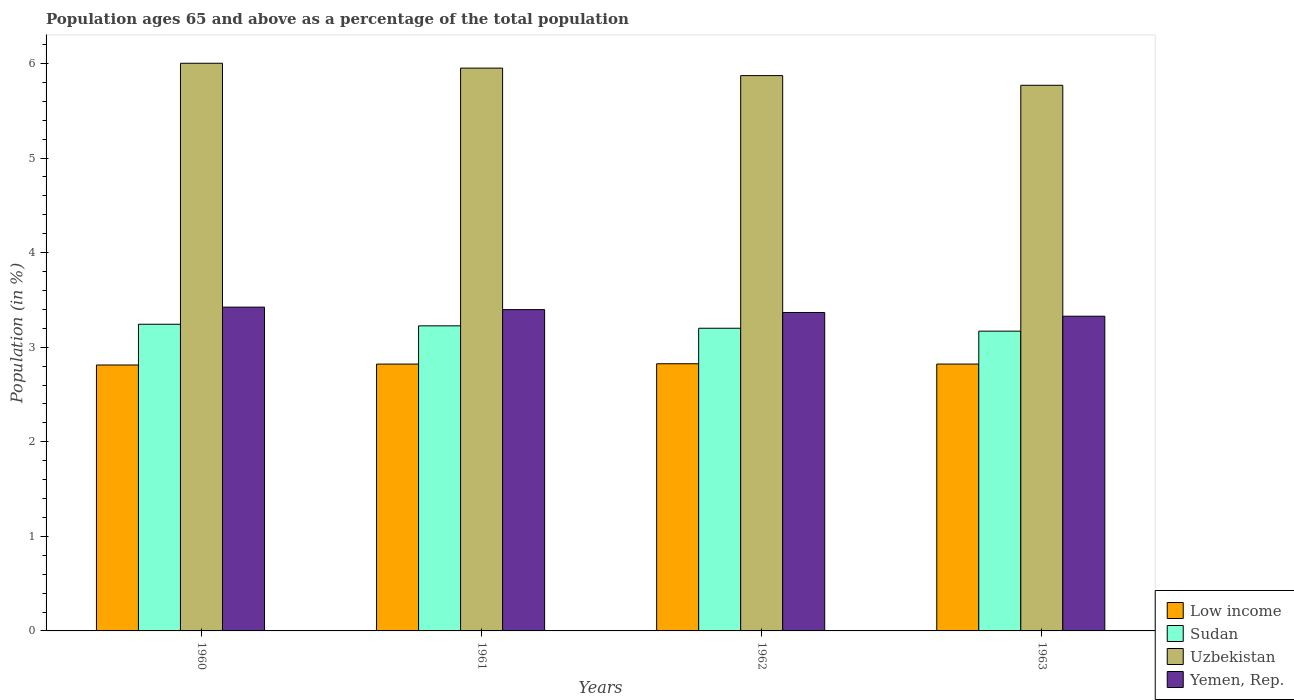How many different coloured bars are there?
Give a very brief answer. 4. How many groups of bars are there?
Ensure brevity in your answer.  4. Are the number of bars on each tick of the X-axis equal?
Ensure brevity in your answer.  Yes. How many bars are there on the 2nd tick from the left?
Your answer should be very brief. 4. What is the label of the 1st group of bars from the left?
Provide a short and direct response. 1960. What is the percentage of the population ages 65 and above in Uzbekistan in 1963?
Ensure brevity in your answer.  5.77. Across all years, what is the maximum percentage of the population ages 65 and above in Yemen, Rep.?
Your response must be concise. 3.42. Across all years, what is the minimum percentage of the population ages 65 and above in Sudan?
Make the answer very short. 3.17. In which year was the percentage of the population ages 65 and above in Sudan maximum?
Offer a very short reply. 1960. In which year was the percentage of the population ages 65 and above in Sudan minimum?
Offer a terse response. 1963. What is the total percentage of the population ages 65 and above in Low income in the graph?
Your response must be concise. 11.28. What is the difference between the percentage of the population ages 65 and above in Uzbekistan in 1960 and that in 1963?
Ensure brevity in your answer.  0.23. What is the difference between the percentage of the population ages 65 and above in Sudan in 1961 and the percentage of the population ages 65 and above in Uzbekistan in 1960?
Make the answer very short. -2.78. What is the average percentage of the population ages 65 and above in Yemen, Rep. per year?
Ensure brevity in your answer.  3.38. In the year 1963, what is the difference between the percentage of the population ages 65 and above in Yemen, Rep. and percentage of the population ages 65 and above in Uzbekistan?
Ensure brevity in your answer.  -2.44. In how many years, is the percentage of the population ages 65 and above in Low income greater than 4.8?
Offer a terse response. 0. What is the ratio of the percentage of the population ages 65 and above in Sudan in 1960 to that in 1963?
Keep it short and to the point. 1.02. What is the difference between the highest and the second highest percentage of the population ages 65 and above in Low income?
Make the answer very short. 0. What is the difference between the highest and the lowest percentage of the population ages 65 and above in Low income?
Your answer should be very brief. 0.01. Is the sum of the percentage of the population ages 65 and above in Low income in 1960 and 1961 greater than the maximum percentage of the population ages 65 and above in Yemen, Rep. across all years?
Provide a short and direct response. Yes. What does the 3rd bar from the left in 1960 represents?
Ensure brevity in your answer.  Uzbekistan. What does the 2nd bar from the right in 1962 represents?
Provide a succinct answer. Uzbekistan. Does the graph contain any zero values?
Your response must be concise. No. Does the graph contain grids?
Make the answer very short. No. Where does the legend appear in the graph?
Your answer should be very brief. Bottom right. How many legend labels are there?
Ensure brevity in your answer.  4. How are the legend labels stacked?
Your answer should be very brief. Vertical. What is the title of the graph?
Your response must be concise. Population ages 65 and above as a percentage of the total population. Does "Venezuela" appear as one of the legend labels in the graph?
Ensure brevity in your answer.  No. What is the label or title of the X-axis?
Give a very brief answer. Years. What is the label or title of the Y-axis?
Your answer should be compact. Population (in %). What is the Population (in %) in Low income in 1960?
Offer a terse response. 2.81. What is the Population (in %) of Sudan in 1960?
Make the answer very short. 3.24. What is the Population (in %) in Uzbekistan in 1960?
Your answer should be very brief. 6. What is the Population (in %) in Yemen, Rep. in 1960?
Your response must be concise. 3.42. What is the Population (in %) of Low income in 1961?
Give a very brief answer. 2.82. What is the Population (in %) in Sudan in 1961?
Keep it short and to the point. 3.23. What is the Population (in %) of Uzbekistan in 1961?
Make the answer very short. 5.95. What is the Population (in %) of Yemen, Rep. in 1961?
Give a very brief answer. 3.4. What is the Population (in %) of Low income in 1962?
Keep it short and to the point. 2.82. What is the Population (in %) in Sudan in 1962?
Offer a very short reply. 3.2. What is the Population (in %) in Uzbekistan in 1962?
Your answer should be very brief. 5.87. What is the Population (in %) in Yemen, Rep. in 1962?
Ensure brevity in your answer.  3.37. What is the Population (in %) in Low income in 1963?
Give a very brief answer. 2.82. What is the Population (in %) in Sudan in 1963?
Provide a short and direct response. 3.17. What is the Population (in %) of Uzbekistan in 1963?
Keep it short and to the point. 5.77. What is the Population (in %) in Yemen, Rep. in 1963?
Provide a succinct answer. 3.33. Across all years, what is the maximum Population (in %) of Low income?
Offer a terse response. 2.82. Across all years, what is the maximum Population (in %) in Sudan?
Your answer should be compact. 3.24. Across all years, what is the maximum Population (in %) of Uzbekistan?
Give a very brief answer. 6. Across all years, what is the maximum Population (in %) in Yemen, Rep.?
Your answer should be compact. 3.42. Across all years, what is the minimum Population (in %) in Low income?
Make the answer very short. 2.81. Across all years, what is the minimum Population (in %) of Sudan?
Your answer should be compact. 3.17. Across all years, what is the minimum Population (in %) in Uzbekistan?
Offer a very short reply. 5.77. Across all years, what is the minimum Population (in %) of Yemen, Rep.?
Your answer should be very brief. 3.33. What is the total Population (in %) in Low income in the graph?
Provide a succinct answer. 11.28. What is the total Population (in %) in Sudan in the graph?
Provide a succinct answer. 12.84. What is the total Population (in %) of Uzbekistan in the graph?
Keep it short and to the point. 23.59. What is the total Population (in %) of Yemen, Rep. in the graph?
Offer a very short reply. 13.51. What is the difference between the Population (in %) of Low income in 1960 and that in 1961?
Your answer should be compact. -0.01. What is the difference between the Population (in %) in Sudan in 1960 and that in 1961?
Provide a succinct answer. 0.02. What is the difference between the Population (in %) of Uzbekistan in 1960 and that in 1961?
Your response must be concise. 0.05. What is the difference between the Population (in %) of Yemen, Rep. in 1960 and that in 1961?
Make the answer very short. 0.03. What is the difference between the Population (in %) of Low income in 1960 and that in 1962?
Offer a terse response. -0.01. What is the difference between the Population (in %) of Sudan in 1960 and that in 1962?
Your answer should be very brief. 0.04. What is the difference between the Population (in %) of Uzbekistan in 1960 and that in 1962?
Offer a terse response. 0.13. What is the difference between the Population (in %) in Yemen, Rep. in 1960 and that in 1962?
Ensure brevity in your answer.  0.06. What is the difference between the Population (in %) of Low income in 1960 and that in 1963?
Provide a succinct answer. -0.01. What is the difference between the Population (in %) of Sudan in 1960 and that in 1963?
Give a very brief answer. 0.07. What is the difference between the Population (in %) of Uzbekistan in 1960 and that in 1963?
Your answer should be compact. 0.23. What is the difference between the Population (in %) in Yemen, Rep. in 1960 and that in 1963?
Your response must be concise. 0.1. What is the difference between the Population (in %) in Low income in 1961 and that in 1962?
Give a very brief answer. -0. What is the difference between the Population (in %) of Sudan in 1961 and that in 1962?
Ensure brevity in your answer.  0.03. What is the difference between the Population (in %) in Uzbekistan in 1961 and that in 1962?
Make the answer very short. 0.08. What is the difference between the Population (in %) of Yemen, Rep. in 1961 and that in 1962?
Keep it short and to the point. 0.03. What is the difference between the Population (in %) of Low income in 1961 and that in 1963?
Your answer should be compact. -0. What is the difference between the Population (in %) in Sudan in 1961 and that in 1963?
Offer a very short reply. 0.06. What is the difference between the Population (in %) in Uzbekistan in 1961 and that in 1963?
Give a very brief answer. 0.18. What is the difference between the Population (in %) of Yemen, Rep. in 1961 and that in 1963?
Your answer should be compact. 0.07. What is the difference between the Population (in %) of Low income in 1962 and that in 1963?
Ensure brevity in your answer.  0. What is the difference between the Population (in %) of Sudan in 1962 and that in 1963?
Provide a succinct answer. 0.03. What is the difference between the Population (in %) of Uzbekistan in 1962 and that in 1963?
Offer a terse response. 0.1. What is the difference between the Population (in %) of Yemen, Rep. in 1962 and that in 1963?
Provide a succinct answer. 0.04. What is the difference between the Population (in %) in Low income in 1960 and the Population (in %) in Sudan in 1961?
Keep it short and to the point. -0.41. What is the difference between the Population (in %) in Low income in 1960 and the Population (in %) in Uzbekistan in 1961?
Your response must be concise. -3.14. What is the difference between the Population (in %) in Low income in 1960 and the Population (in %) in Yemen, Rep. in 1961?
Give a very brief answer. -0.59. What is the difference between the Population (in %) of Sudan in 1960 and the Population (in %) of Uzbekistan in 1961?
Your answer should be compact. -2.71. What is the difference between the Population (in %) of Sudan in 1960 and the Population (in %) of Yemen, Rep. in 1961?
Your response must be concise. -0.15. What is the difference between the Population (in %) in Uzbekistan in 1960 and the Population (in %) in Yemen, Rep. in 1961?
Your response must be concise. 2.6. What is the difference between the Population (in %) of Low income in 1960 and the Population (in %) of Sudan in 1962?
Provide a short and direct response. -0.39. What is the difference between the Population (in %) in Low income in 1960 and the Population (in %) in Uzbekistan in 1962?
Keep it short and to the point. -3.06. What is the difference between the Population (in %) of Low income in 1960 and the Population (in %) of Yemen, Rep. in 1962?
Give a very brief answer. -0.55. What is the difference between the Population (in %) in Sudan in 1960 and the Population (in %) in Uzbekistan in 1962?
Your response must be concise. -2.63. What is the difference between the Population (in %) of Sudan in 1960 and the Population (in %) of Yemen, Rep. in 1962?
Your answer should be very brief. -0.12. What is the difference between the Population (in %) in Uzbekistan in 1960 and the Population (in %) in Yemen, Rep. in 1962?
Your answer should be very brief. 2.64. What is the difference between the Population (in %) of Low income in 1960 and the Population (in %) of Sudan in 1963?
Offer a very short reply. -0.36. What is the difference between the Population (in %) of Low income in 1960 and the Population (in %) of Uzbekistan in 1963?
Ensure brevity in your answer.  -2.96. What is the difference between the Population (in %) of Low income in 1960 and the Population (in %) of Yemen, Rep. in 1963?
Provide a succinct answer. -0.52. What is the difference between the Population (in %) of Sudan in 1960 and the Population (in %) of Uzbekistan in 1963?
Make the answer very short. -2.53. What is the difference between the Population (in %) in Sudan in 1960 and the Population (in %) in Yemen, Rep. in 1963?
Offer a terse response. -0.09. What is the difference between the Population (in %) in Uzbekistan in 1960 and the Population (in %) in Yemen, Rep. in 1963?
Keep it short and to the point. 2.67. What is the difference between the Population (in %) of Low income in 1961 and the Population (in %) of Sudan in 1962?
Your answer should be compact. -0.38. What is the difference between the Population (in %) of Low income in 1961 and the Population (in %) of Uzbekistan in 1962?
Ensure brevity in your answer.  -3.05. What is the difference between the Population (in %) of Low income in 1961 and the Population (in %) of Yemen, Rep. in 1962?
Offer a terse response. -0.55. What is the difference between the Population (in %) in Sudan in 1961 and the Population (in %) in Uzbekistan in 1962?
Offer a terse response. -2.65. What is the difference between the Population (in %) in Sudan in 1961 and the Population (in %) in Yemen, Rep. in 1962?
Your response must be concise. -0.14. What is the difference between the Population (in %) in Uzbekistan in 1961 and the Population (in %) in Yemen, Rep. in 1962?
Give a very brief answer. 2.58. What is the difference between the Population (in %) in Low income in 1961 and the Population (in %) in Sudan in 1963?
Your answer should be very brief. -0.35. What is the difference between the Population (in %) in Low income in 1961 and the Population (in %) in Uzbekistan in 1963?
Ensure brevity in your answer.  -2.95. What is the difference between the Population (in %) in Low income in 1961 and the Population (in %) in Yemen, Rep. in 1963?
Offer a very short reply. -0.51. What is the difference between the Population (in %) in Sudan in 1961 and the Population (in %) in Uzbekistan in 1963?
Offer a very short reply. -2.54. What is the difference between the Population (in %) of Sudan in 1961 and the Population (in %) of Yemen, Rep. in 1963?
Provide a short and direct response. -0.1. What is the difference between the Population (in %) of Uzbekistan in 1961 and the Population (in %) of Yemen, Rep. in 1963?
Give a very brief answer. 2.62. What is the difference between the Population (in %) in Low income in 1962 and the Population (in %) in Sudan in 1963?
Your response must be concise. -0.34. What is the difference between the Population (in %) in Low income in 1962 and the Population (in %) in Uzbekistan in 1963?
Provide a succinct answer. -2.94. What is the difference between the Population (in %) in Low income in 1962 and the Population (in %) in Yemen, Rep. in 1963?
Offer a terse response. -0.5. What is the difference between the Population (in %) of Sudan in 1962 and the Population (in %) of Uzbekistan in 1963?
Your answer should be very brief. -2.57. What is the difference between the Population (in %) of Sudan in 1962 and the Population (in %) of Yemen, Rep. in 1963?
Offer a terse response. -0.13. What is the difference between the Population (in %) in Uzbekistan in 1962 and the Population (in %) in Yemen, Rep. in 1963?
Ensure brevity in your answer.  2.54. What is the average Population (in %) of Low income per year?
Your answer should be very brief. 2.82. What is the average Population (in %) in Sudan per year?
Your answer should be very brief. 3.21. What is the average Population (in %) of Uzbekistan per year?
Your answer should be compact. 5.9. What is the average Population (in %) of Yemen, Rep. per year?
Give a very brief answer. 3.38. In the year 1960, what is the difference between the Population (in %) in Low income and Population (in %) in Sudan?
Your answer should be very brief. -0.43. In the year 1960, what is the difference between the Population (in %) of Low income and Population (in %) of Uzbekistan?
Your response must be concise. -3.19. In the year 1960, what is the difference between the Population (in %) of Low income and Population (in %) of Yemen, Rep.?
Keep it short and to the point. -0.61. In the year 1960, what is the difference between the Population (in %) in Sudan and Population (in %) in Uzbekistan?
Offer a very short reply. -2.76. In the year 1960, what is the difference between the Population (in %) of Sudan and Population (in %) of Yemen, Rep.?
Your answer should be very brief. -0.18. In the year 1960, what is the difference between the Population (in %) of Uzbekistan and Population (in %) of Yemen, Rep.?
Provide a succinct answer. 2.58. In the year 1961, what is the difference between the Population (in %) in Low income and Population (in %) in Sudan?
Your answer should be compact. -0.4. In the year 1961, what is the difference between the Population (in %) of Low income and Population (in %) of Uzbekistan?
Provide a short and direct response. -3.13. In the year 1961, what is the difference between the Population (in %) of Low income and Population (in %) of Yemen, Rep.?
Provide a succinct answer. -0.58. In the year 1961, what is the difference between the Population (in %) of Sudan and Population (in %) of Uzbekistan?
Give a very brief answer. -2.72. In the year 1961, what is the difference between the Population (in %) in Sudan and Population (in %) in Yemen, Rep.?
Give a very brief answer. -0.17. In the year 1961, what is the difference between the Population (in %) in Uzbekistan and Population (in %) in Yemen, Rep.?
Offer a very short reply. 2.55. In the year 1962, what is the difference between the Population (in %) of Low income and Population (in %) of Sudan?
Offer a very short reply. -0.38. In the year 1962, what is the difference between the Population (in %) of Low income and Population (in %) of Uzbekistan?
Your response must be concise. -3.05. In the year 1962, what is the difference between the Population (in %) of Low income and Population (in %) of Yemen, Rep.?
Make the answer very short. -0.54. In the year 1962, what is the difference between the Population (in %) of Sudan and Population (in %) of Uzbekistan?
Keep it short and to the point. -2.67. In the year 1962, what is the difference between the Population (in %) of Sudan and Population (in %) of Yemen, Rep.?
Your answer should be very brief. -0.17. In the year 1962, what is the difference between the Population (in %) in Uzbekistan and Population (in %) in Yemen, Rep.?
Offer a terse response. 2.5. In the year 1963, what is the difference between the Population (in %) in Low income and Population (in %) in Sudan?
Your answer should be compact. -0.35. In the year 1963, what is the difference between the Population (in %) of Low income and Population (in %) of Uzbekistan?
Offer a very short reply. -2.95. In the year 1963, what is the difference between the Population (in %) of Low income and Population (in %) of Yemen, Rep.?
Keep it short and to the point. -0.51. In the year 1963, what is the difference between the Population (in %) in Sudan and Population (in %) in Uzbekistan?
Provide a succinct answer. -2.6. In the year 1963, what is the difference between the Population (in %) in Sudan and Population (in %) in Yemen, Rep.?
Ensure brevity in your answer.  -0.16. In the year 1963, what is the difference between the Population (in %) of Uzbekistan and Population (in %) of Yemen, Rep.?
Your response must be concise. 2.44. What is the ratio of the Population (in %) of Uzbekistan in 1960 to that in 1961?
Ensure brevity in your answer.  1.01. What is the ratio of the Population (in %) of Yemen, Rep. in 1960 to that in 1961?
Offer a terse response. 1.01. What is the ratio of the Population (in %) of Sudan in 1960 to that in 1962?
Make the answer very short. 1.01. What is the ratio of the Population (in %) of Uzbekistan in 1960 to that in 1962?
Give a very brief answer. 1.02. What is the ratio of the Population (in %) in Yemen, Rep. in 1960 to that in 1962?
Keep it short and to the point. 1.02. What is the ratio of the Population (in %) of Uzbekistan in 1960 to that in 1963?
Keep it short and to the point. 1.04. What is the ratio of the Population (in %) of Yemen, Rep. in 1960 to that in 1963?
Provide a short and direct response. 1.03. What is the ratio of the Population (in %) of Sudan in 1961 to that in 1962?
Give a very brief answer. 1.01. What is the ratio of the Population (in %) in Uzbekistan in 1961 to that in 1962?
Your answer should be very brief. 1.01. What is the ratio of the Population (in %) of Yemen, Rep. in 1961 to that in 1962?
Provide a succinct answer. 1.01. What is the ratio of the Population (in %) of Low income in 1961 to that in 1963?
Offer a very short reply. 1. What is the ratio of the Population (in %) of Sudan in 1961 to that in 1963?
Offer a very short reply. 1.02. What is the ratio of the Population (in %) in Uzbekistan in 1961 to that in 1963?
Your response must be concise. 1.03. What is the ratio of the Population (in %) in Yemen, Rep. in 1961 to that in 1963?
Offer a terse response. 1.02. What is the ratio of the Population (in %) of Sudan in 1962 to that in 1963?
Ensure brevity in your answer.  1.01. What is the ratio of the Population (in %) of Uzbekistan in 1962 to that in 1963?
Your answer should be very brief. 1.02. What is the ratio of the Population (in %) in Yemen, Rep. in 1962 to that in 1963?
Keep it short and to the point. 1.01. What is the difference between the highest and the second highest Population (in %) in Low income?
Give a very brief answer. 0. What is the difference between the highest and the second highest Population (in %) in Sudan?
Make the answer very short. 0.02. What is the difference between the highest and the second highest Population (in %) of Uzbekistan?
Your answer should be very brief. 0.05. What is the difference between the highest and the second highest Population (in %) in Yemen, Rep.?
Provide a short and direct response. 0.03. What is the difference between the highest and the lowest Population (in %) in Low income?
Give a very brief answer. 0.01. What is the difference between the highest and the lowest Population (in %) of Sudan?
Offer a terse response. 0.07. What is the difference between the highest and the lowest Population (in %) in Uzbekistan?
Keep it short and to the point. 0.23. What is the difference between the highest and the lowest Population (in %) of Yemen, Rep.?
Make the answer very short. 0.1. 